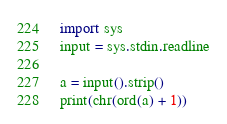<code> <loc_0><loc_0><loc_500><loc_500><_Python_>import sys
input = sys.stdin.readline

a = input().strip()
print(chr(ord(a) + 1))
</code> 